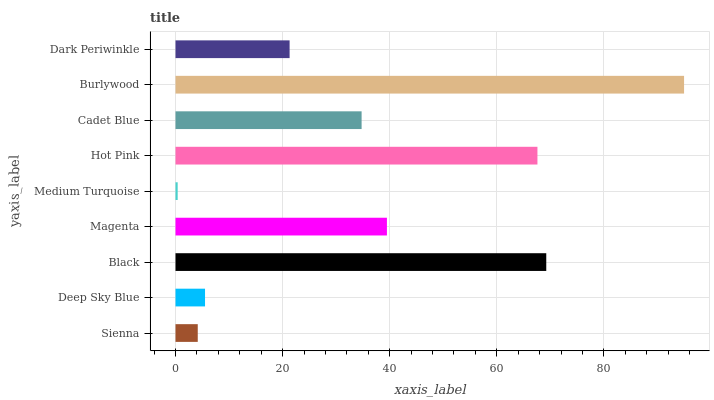Is Medium Turquoise the minimum?
Answer yes or no. Yes. Is Burlywood the maximum?
Answer yes or no. Yes. Is Deep Sky Blue the minimum?
Answer yes or no. No. Is Deep Sky Blue the maximum?
Answer yes or no. No. Is Deep Sky Blue greater than Sienna?
Answer yes or no. Yes. Is Sienna less than Deep Sky Blue?
Answer yes or no. Yes. Is Sienna greater than Deep Sky Blue?
Answer yes or no. No. Is Deep Sky Blue less than Sienna?
Answer yes or no. No. Is Cadet Blue the high median?
Answer yes or no. Yes. Is Cadet Blue the low median?
Answer yes or no. Yes. Is Magenta the high median?
Answer yes or no. No. Is Magenta the low median?
Answer yes or no. No. 